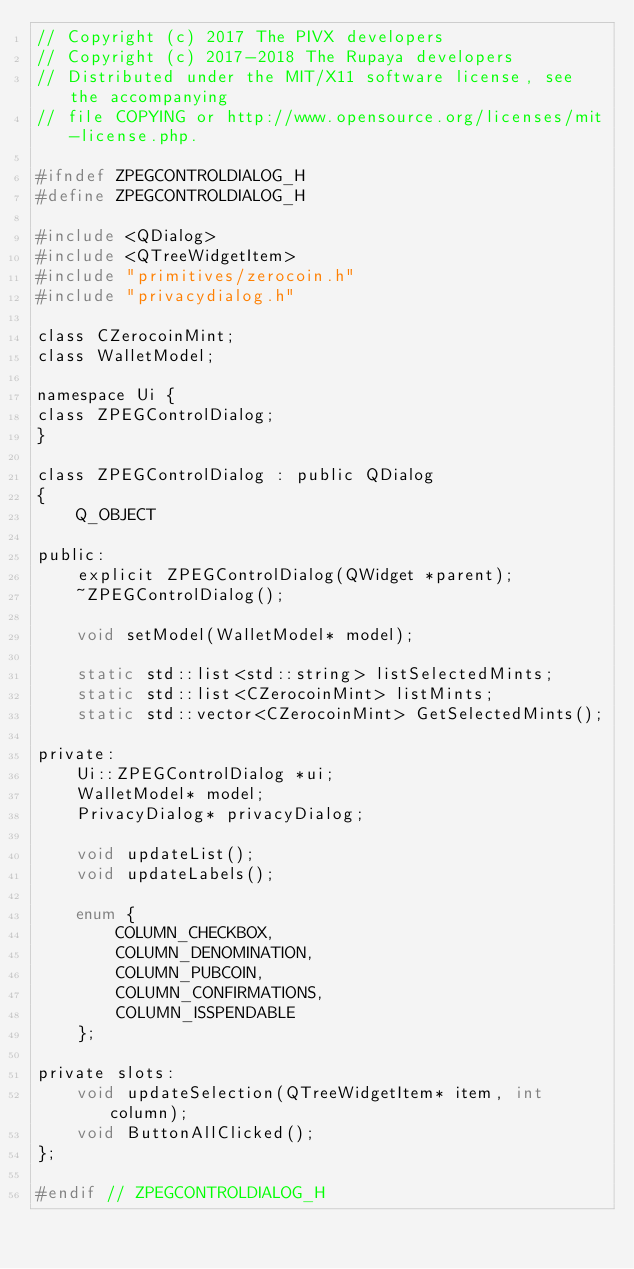Convert code to text. <code><loc_0><loc_0><loc_500><loc_500><_C_>// Copyright (c) 2017 The PIVX developers
// Copyright (c) 2017-2018 The Rupaya developers
// Distributed under the MIT/X11 software license, see the accompanying
// file COPYING or http://www.opensource.org/licenses/mit-license.php.

#ifndef ZPEGCONTROLDIALOG_H
#define ZPEGCONTROLDIALOG_H

#include <QDialog>
#include <QTreeWidgetItem>
#include "primitives/zerocoin.h"
#include "privacydialog.h"

class CZerocoinMint;
class WalletModel;

namespace Ui {
class ZPEGControlDialog;
}

class ZPEGControlDialog : public QDialog
{
    Q_OBJECT

public:
    explicit ZPEGControlDialog(QWidget *parent);
    ~ZPEGControlDialog();

    void setModel(WalletModel* model);

    static std::list<std::string> listSelectedMints;
    static std::list<CZerocoinMint> listMints;
    static std::vector<CZerocoinMint> GetSelectedMints();

private:
    Ui::ZPEGControlDialog *ui;
    WalletModel* model;
    PrivacyDialog* privacyDialog;

    void updateList();
    void updateLabels();

    enum {
        COLUMN_CHECKBOX,
        COLUMN_DENOMINATION,
        COLUMN_PUBCOIN,
        COLUMN_CONFIRMATIONS,
        COLUMN_ISSPENDABLE
    };

private slots:
    void updateSelection(QTreeWidgetItem* item, int column);
    void ButtonAllClicked();
};

#endif // ZPEGCONTROLDIALOG_H
</code> 